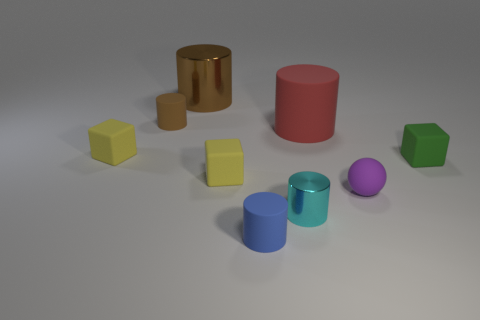Is the color of the rubber cylinder that is on the left side of the large brown metal object the same as the big metal thing?
Make the answer very short. Yes. What is the material of the brown thing on the right side of the brown object that is on the left side of the brown metallic cylinder?
Offer a very short reply. Metal. There is a large red thing that is made of the same material as the green block; what shape is it?
Offer a very short reply. Cylinder. Is there anything else that is the same shape as the purple thing?
Offer a very short reply. No. How many large brown shiny things are to the left of the large matte object?
Your answer should be very brief. 1. Are any blue cylinders visible?
Offer a very short reply. Yes. What is the color of the big cylinder to the left of the tiny matte cylinder that is in front of the tiny object that is behind the big red matte object?
Give a very brief answer. Brown. There is a metal object behind the red thing; are there any yellow cubes that are on the left side of it?
Your response must be concise. Yes. There is a small rubber cylinder that is behind the big red matte object; is its color the same as the thing that is behind the brown rubber thing?
Your response must be concise. Yes. What number of cyan objects have the same size as the brown metallic cylinder?
Your answer should be very brief. 0. 